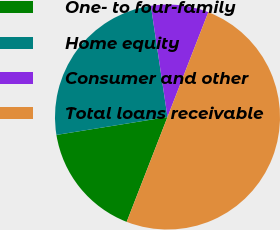<chart> <loc_0><loc_0><loc_500><loc_500><pie_chart><fcel>One- to four-family<fcel>Home equity<fcel>Consumer and other<fcel>Total loans receivable<nl><fcel>16.55%<fcel>25.18%<fcel>8.27%<fcel>50.0%<nl></chart> 